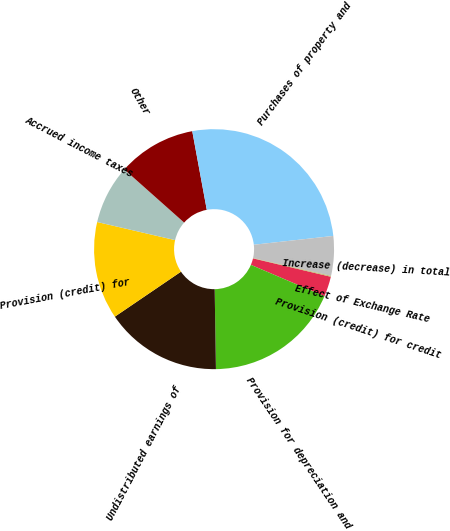Convert chart to OTSL. <chart><loc_0><loc_0><loc_500><loc_500><pie_chart><fcel>Provision (credit) for credit<fcel>Provision for depreciation and<fcel>Undistributed earnings of<fcel>Provision (credit) for<fcel>Accrued income taxes<fcel>Other<fcel>Purchases of property and<fcel>Increase (decrease) in total<fcel>Effect of Exchange Rate<nl><fcel>2.72%<fcel>18.34%<fcel>15.74%<fcel>13.14%<fcel>7.93%<fcel>10.53%<fcel>26.15%<fcel>5.33%<fcel>0.12%<nl></chart> 